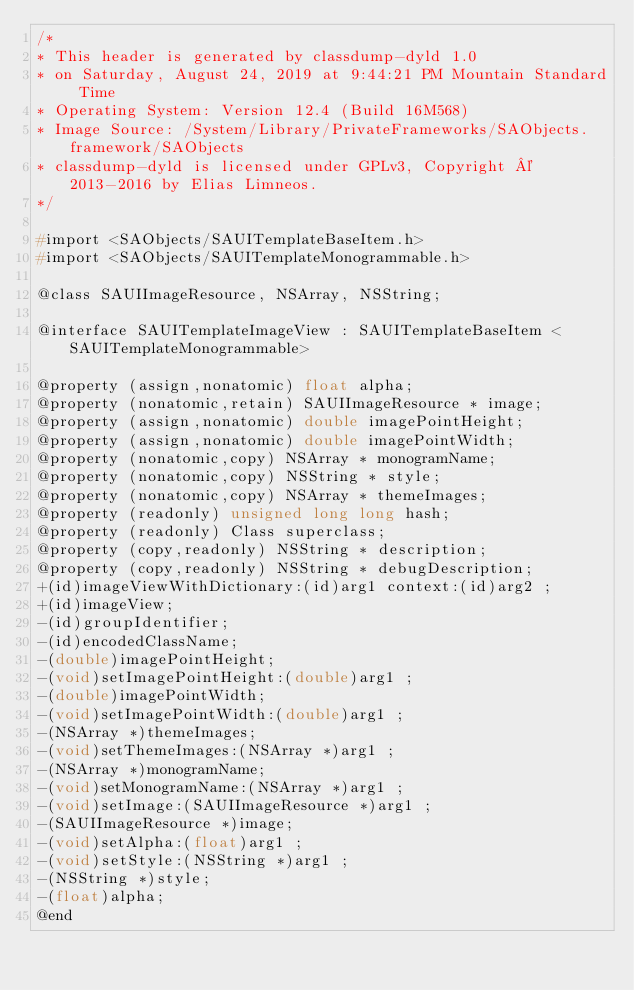Convert code to text. <code><loc_0><loc_0><loc_500><loc_500><_C_>/*
* This header is generated by classdump-dyld 1.0
* on Saturday, August 24, 2019 at 9:44:21 PM Mountain Standard Time
* Operating System: Version 12.4 (Build 16M568)
* Image Source: /System/Library/PrivateFrameworks/SAObjects.framework/SAObjects
* classdump-dyld is licensed under GPLv3, Copyright © 2013-2016 by Elias Limneos.
*/

#import <SAObjects/SAUITemplateBaseItem.h>
#import <SAObjects/SAUITemplateMonogrammable.h>

@class SAUIImageResource, NSArray, NSString;

@interface SAUITemplateImageView : SAUITemplateBaseItem <SAUITemplateMonogrammable>

@property (assign,nonatomic) float alpha; 
@property (nonatomic,retain) SAUIImageResource * image; 
@property (assign,nonatomic) double imagePointHeight; 
@property (assign,nonatomic) double imagePointWidth; 
@property (nonatomic,copy) NSArray * monogramName; 
@property (nonatomic,copy) NSString * style; 
@property (nonatomic,copy) NSArray * themeImages; 
@property (readonly) unsigned long long hash; 
@property (readonly) Class superclass; 
@property (copy,readonly) NSString * description; 
@property (copy,readonly) NSString * debugDescription; 
+(id)imageViewWithDictionary:(id)arg1 context:(id)arg2 ;
+(id)imageView;
-(id)groupIdentifier;
-(id)encodedClassName;
-(double)imagePointHeight;
-(void)setImagePointHeight:(double)arg1 ;
-(double)imagePointWidth;
-(void)setImagePointWidth:(double)arg1 ;
-(NSArray *)themeImages;
-(void)setThemeImages:(NSArray *)arg1 ;
-(NSArray *)monogramName;
-(void)setMonogramName:(NSArray *)arg1 ;
-(void)setImage:(SAUIImageResource *)arg1 ;
-(SAUIImageResource *)image;
-(void)setAlpha:(float)arg1 ;
-(void)setStyle:(NSString *)arg1 ;
-(NSString *)style;
-(float)alpha;
@end

</code> 